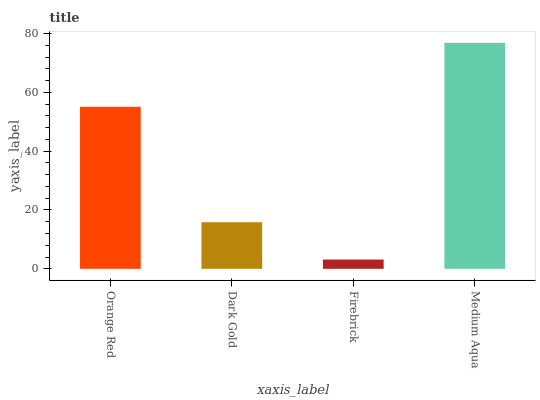Is Firebrick the minimum?
Answer yes or no. Yes. Is Medium Aqua the maximum?
Answer yes or no. Yes. Is Dark Gold the minimum?
Answer yes or no. No. Is Dark Gold the maximum?
Answer yes or no. No. Is Orange Red greater than Dark Gold?
Answer yes or no. Yes. Is Dark Gold less than Orange Red?
Answer yes or no. Yes. Is Dark Gold greater than Orange Red?
Answer yes or no. No. Is Orange Red less than Dark Gold?
Answer yes or no. No. Is Orange Red the high median?
Answer yes or no. Yes. Is Dark Gold the low median?
Answer yes or no. Yes. Is Medium Aqua the high median?
Answer yes or no. No. Is Firebrick the low median?
Answer yes or no. No. 